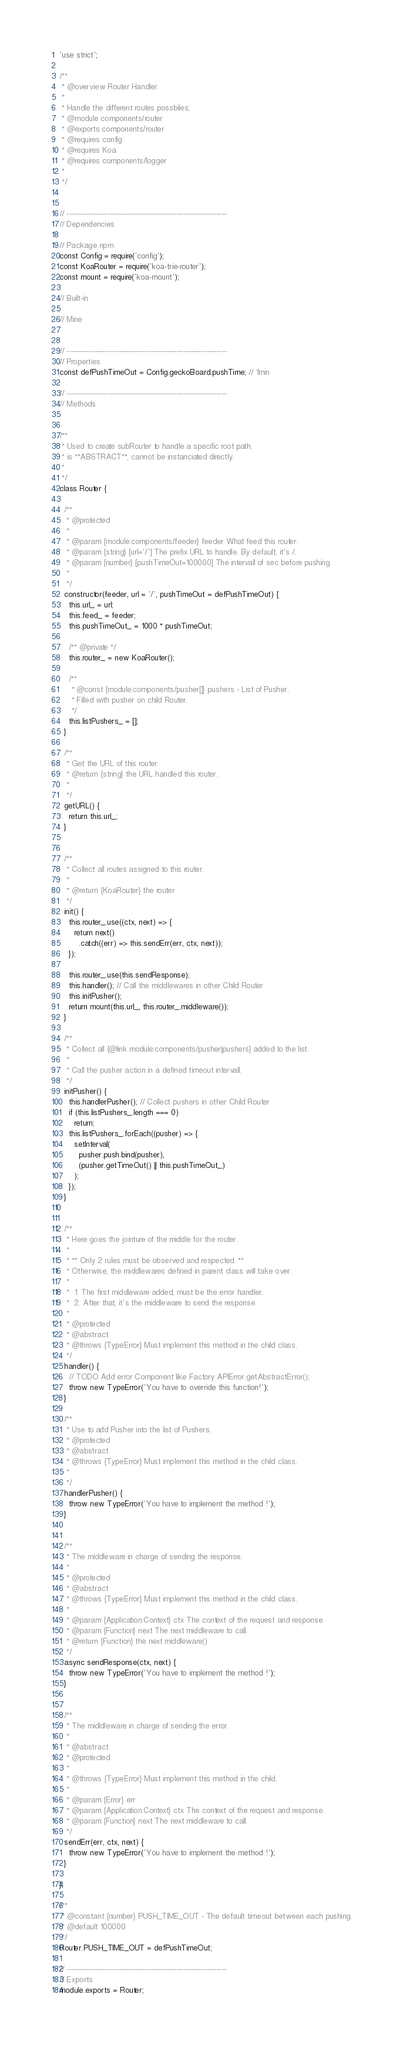Convert code to text. <code><loc_0><loc_0><loc_500><loc_500><_JavaScript_>'use strict';

/**
 * @overview Router Handler
 *
 * Handle the different routes possbiles;
 * @module components/router
 * @exports components/router
 * @requires config
 * @requires Koa
 * @requires components/logger
 *
 */


// -------------------------------------------------------------------
// Dependencies

// Package npm
const Config = require('config');
const KoaRouter = require('koa-trie-router');
const mount = require('koa-mount');

// Built-in

// Mine


// -------------------------------------------------------------------
// Properties
const defPushTimeOut = Config.geckoBoard.pushTime; // 1min

// -------------------------------------------------------------------
// Methods


/**
 * Used to create subRouter to handle a specific root path.
 * is **ABSTRACT**, cannot be instanciated directly.
 *
 */
class Router {

  /**
   * @protected
   *
   * @param {module:components/feeder} feeder What feed this router.
   * @param {string} [url='/'] The prefix URL to handle. By default, it's /.
   * @param {number} [pushTimeOut=100000] The intervall of sec before pushing
   *
   */
  constructor(feeder, url = '/', pushTimeOut = defPushTimeOut) {
    this.url_ = url;
    this.feed_ = feeder;
    this.pushTimeOut_ = 1000 * pushTimeOut;

    /** @private */
    this.router_ = new KoaRouter();

    /**
     * @const {module:components/pusher[]} pushers - List of Pusher.
     * Filled with pusher on child Router.
     */
    this.listPushers_ = [];
  }

  /**
   * Get the URL of this router.
   * @return {string} the URL handled this router.
   *
   */
  getURL() {
    return this.url_;
  }


  /**
   * Collect all routes assigned to this router.
   *
   * @return {KoaRouter} the router
   */
  init() {
    this.router_.use((ctx, next) => {
      return next()
        .catch((err) => this.sendErr(err, ctx, next));
    });

    this.router_.use(this.sendResponse);
    this.handler(); // Call the middlewares in other Child Router
    this.initPusher();
    return mount(this.url_, this.router_.middleware());
  }

  /**
   * Collect all {@link module:components/pusher|pushers} added to the list.
   *
   * Call the pusher action in a defined timeout intervall.
   */
  initPusher() {
    this.handlerPusher(); // Collect pushers in other Child Router
    if (this.listPushers_.length === 0)
      return;
    this.listPushers_.forEach((pusher) => {
      setInterval(
        pusher.push.bind(pusher),
        (pusher.getTimeOut() || this.pushTimeOut_)
      );
    });
  }


  /**
   * Here goes the jointure of the middle for the router.
   *
   * ** Only 2 rules must be observed and respected. **
   * Otherwise, the middlewares defined in parent class will take over.
   *
   *  1. The first middleware added, must be the error handler.
   *  2. After that, it's the middleware to send the response.
   *
   * @protected
   * @abstract
   * @throws {TypeError} Must implement this method in the child class.
   */
  handler() {
    // TODO Add error Component like Factory APIError.getAbstractError();
    throw new TypeError('You have to override this function!');
  }

  /**
   * Use to add Pusher into the list of Pushers.
   * @protected
   * @abstract
   * @throws {TypeError} Must implement this method in the child class.
   *
   */
  handlerPusher() {
    throw new TypeError('You have to implement the method !');
  }


  /**
   * The middleware in charge of sending the response.
   *
   * @protected
   * @abstract
   * @throws {TypeError} Must implement this method in the child class.
   *
   * @param {Application.Context} ctx The context of the request and response.
   * @param {Function} next The next middleware to call.
   * @return {Function} the next middleware()
   */
  async sendResponse(ctx, next) {
    throw new TypeError('You have to implement the method !');
  }


  /**
   * The midldleware in charge of sending the error.
   *
   * @abstract
   * @protected
   *
   * @throws {TypeError} Must implement this method in the child.
   *
   * @param {Error} err
   * @param {Application.Context} ctx The context of the request and response.
   * @param {Function} next The next middleware to call.
   */
  sendErr(err, ctx, next) {
    throw new TypeError('You have to implement the method !');
  }

};

/**
 * @constant {number} PUSH_TIME_OUT - The default timeout between each pushing.
 * @default 100000
 */
Router.PUSH_TIME_OUT = defPushTimeOut;

// -------------------------------------------------------------------
// Exports
module.exports = Router;
</code> 